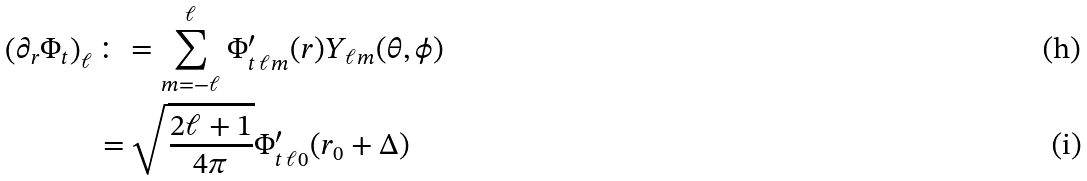<formula> <loc_0><loc_0><loc_500><loc_500>\left ( \partial _ { r } \Phi _ { t } \right ) _ { \ell } & \colon = \sum _ { m = - \ell } ^ { \ell } \Phi ^ { \prime } _ { t \, \ell m } ( r ) Y _ { \ell m } ( \theta , \phi ) \\ & = \sqrt { \frac { 2 \ell + 1 } { 4 \pi } } \Phi ^ { \prime } _ { t \, \ell 0 } ( r _ { 0 } + \Delta )</formula> 